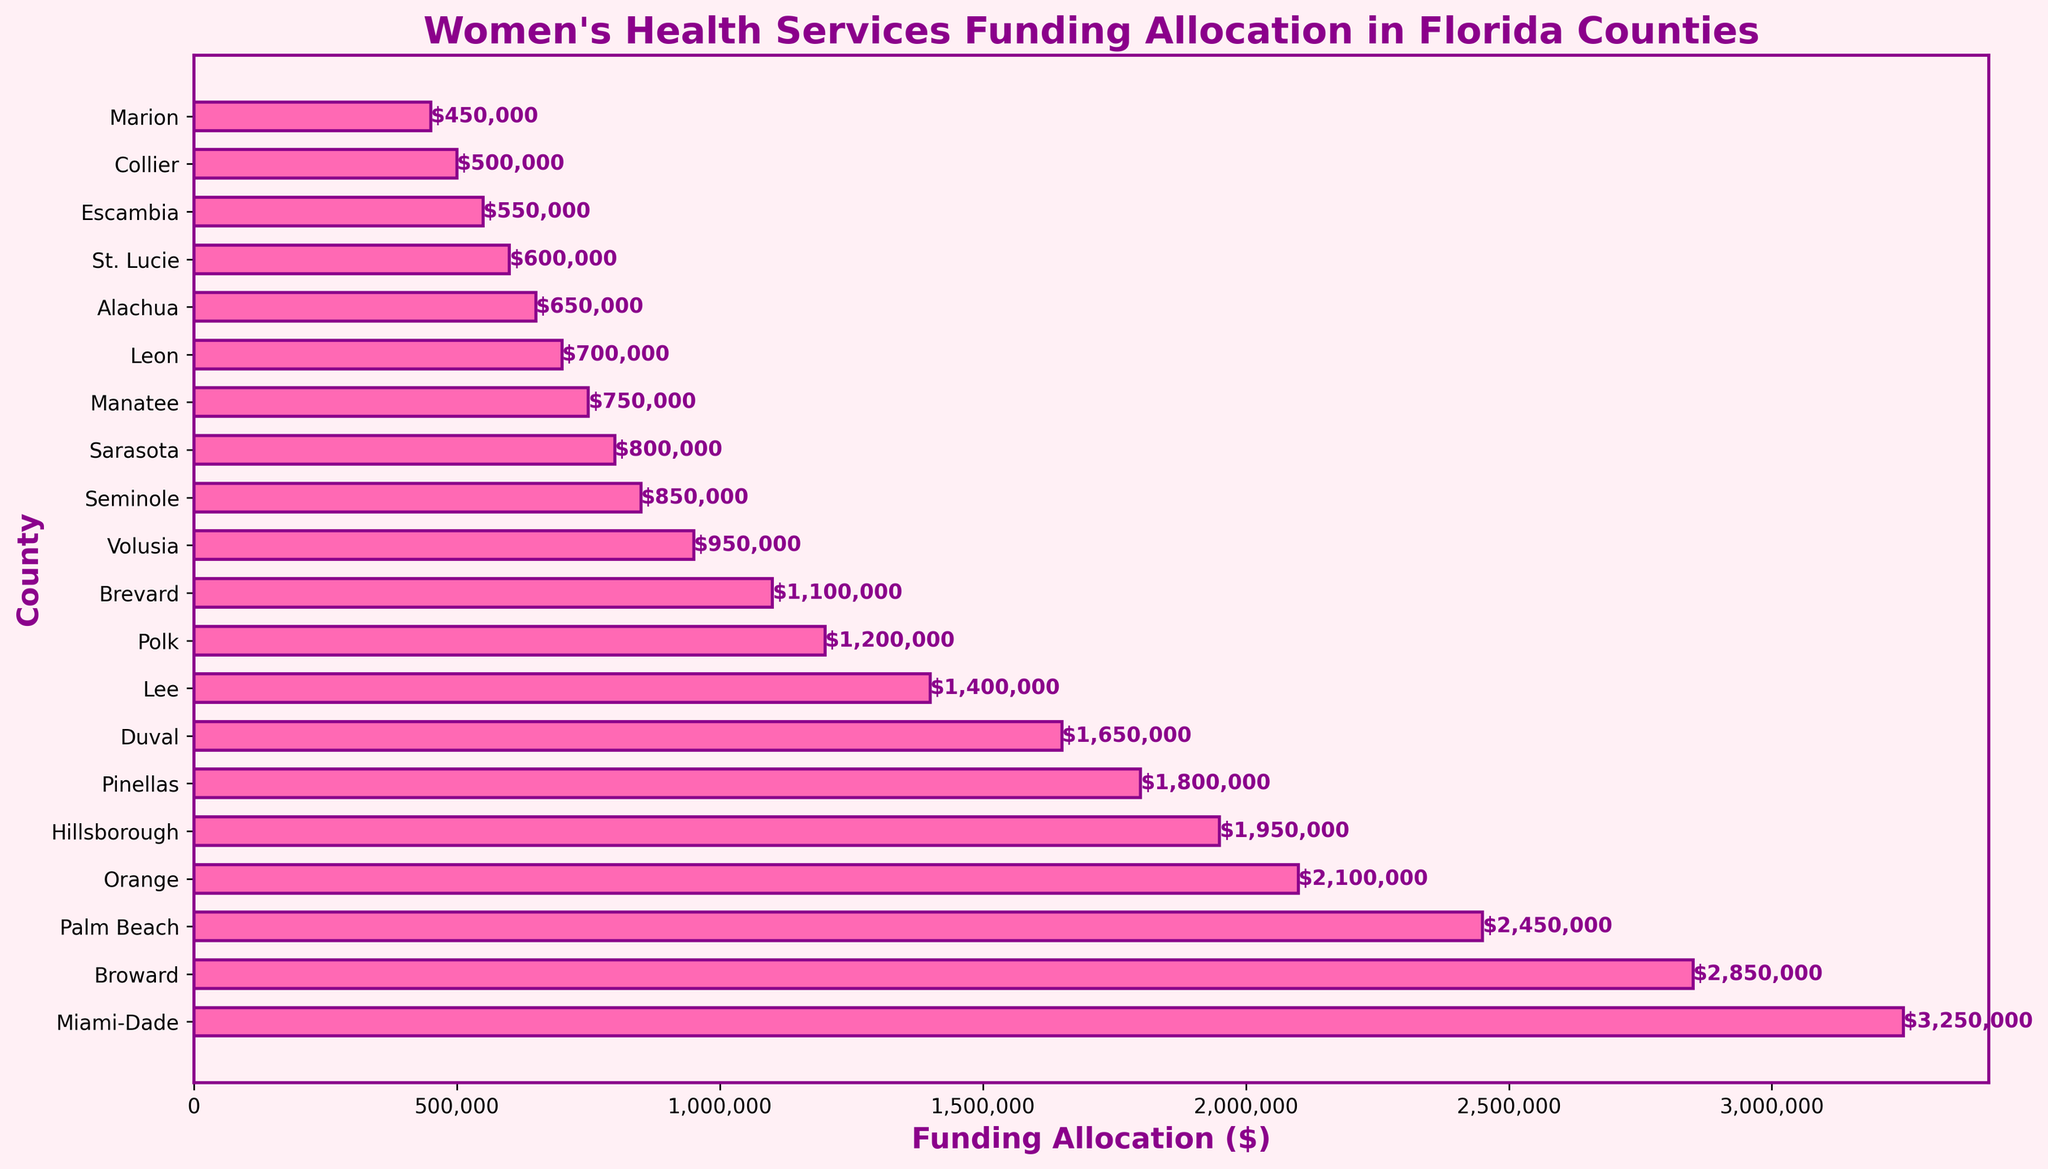What is the total funding allocation for the top 3 counties? The top 3 counties are Miami-Dade, Broward, and Palm Beach. Their funding allocations are $3,250,000, $2,850,000, and $2,450,000 respectively. Sum these values: $3,250,000 + $2,850,000 + $2,450,000 equals $8,550,000.
Answer: $8,550,000 Which county has the lowest funding allocation and how much is it? By looking at the lengths of the bars, Marion County has the shortest bar, indicating it has the lowest funding allocation of $450,000.
Answer: Marion, $450,000 What is the difference in funding allocation between Miami-Dade and Hillsborough counties? Miami-Dade has $3,250,000 and Hillsborough has $1,950,000. Subtract the smaller amount from the larger: $3,250,000 - $1,950,000 equals $1,300,000.
Answer: $1,300,000 Which counties receive more than $2,000,000 in funding? Counties with bars extending beyond the $2,000,000 mark are Miami-Dade, Broward, Palm Beach, and Orange.
Answer: Miami-Dade, Broward, Palm Beach, Orange What is the average funding allocation for all counties? Sum the funding allocations of all counties and divide by the number of counties (20). The total sum is $20,950,000. The average is $20,950,000 / 20 = $1,047,500.
Answer: $1,047,500 Comparing Orange County and Hillsborough County, which one receives more funding? The bar for Orange County is longer than the bar for Hillsborough County indicating Orange County receives $2,100,000 while Hillsborough receives $1,950,000.
Answer: Orange What is the combined funding allocation for Leon, Alachua, and St. Lucie counties? Their funding allocations are $700,000, $650,000, and $600,000 respectively. Add the values: $700,000 + $650,000 + $600,000 equals $1,950,000.
Answer: $1,950,000 Are there more counties with funding allocations above $1,000,000 or below $1,000,000? There are 10 counties with funding above $1,000,000 (Miami-Dade to Polk) and 10 counties with funding below $1,000,000 (Brevard to Marion). Hence there are equal numbers.
Answer: Equal Which county ranks fifth in terms of funding allocation and what is the exact amount? The fifth county in descending order is Hillsborough with a funding allocation of $1,950,000.
Answer: Hillsborough, $1,950,000 